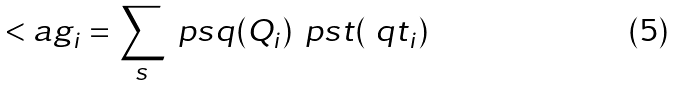<formula> <loc_0><loc_0><loc_500><loc_500>< a g _ { i } = \sum _ { s } \ p s q ( Q _ { i } ) \, \ p s t ( \ q t _ { i } )</formula> 